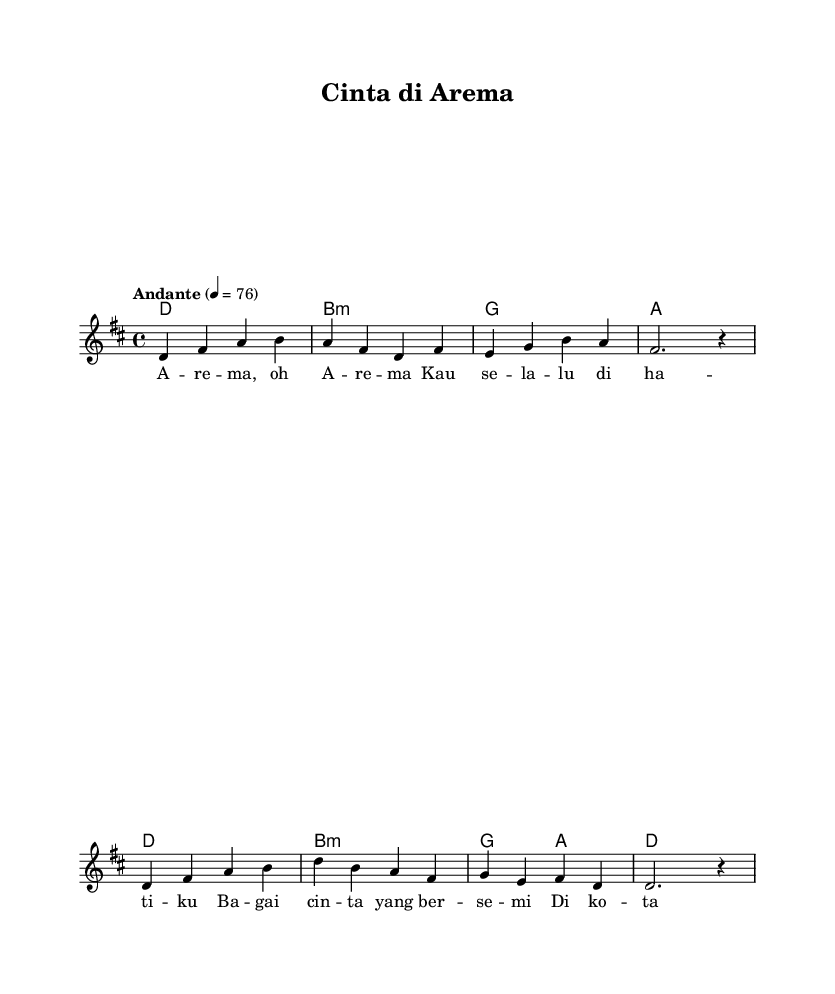What is the key signature of this music? The key signature is indicated at the beginning of the staff, showing two sharps (F# and C#), which corresponds to the key of D major.
Answer: D major What is the time signature of this piece? The time signature is found at the beginning of the score after the key signature. It is noted as 4/4, indicating that there are four beats in each measure and the quarter note gets one beat.
Answer: 4/4 What is the tempo marking for this piece? The tempo marking is indicated above the staff, specifying "Andante" with a metronome marking of 76. This suggests a moderately slow pace.
Answer: Andante, 76 What is the first chord played in the harmonies? The first chord in the chord progression is found at the start of the harmonies section, labeled as D major (D1), which provides the tonal foundation for the piece.
Answer: D major How many measures are in the melody section? To find the number of measures in the melody, one can count the notated segments separated by bar lines in the given melody. There are a total of 8 measures present.
Answer: 8 What type of song structure is represented in this piece? This piece has a verse structure, evident from the lyrics section where a specific lyrical theme is repeated. The lyrics are formatted to align with the musical phrases, indicating a romantic song structure.
Answer: Verse What is the central theme expressed in the lyrics? The central theme can be derived from the lyrics which express love and affection, specifically mentioning "Arema" and "Malang", highlighting a romantic connection to the football club and the city.
Answer: Love and affection 